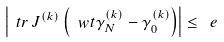<formula> <loc_0><loc_0><loc_500><loc_500>\left | \ t r \, J ^ { ( k ) } \left ( \ w t \gamma ^ { ( k ) } _ { N } - \gamma ^ { ( k ) } _ { 0 } \right ) \right | \leq \ e</formula> 